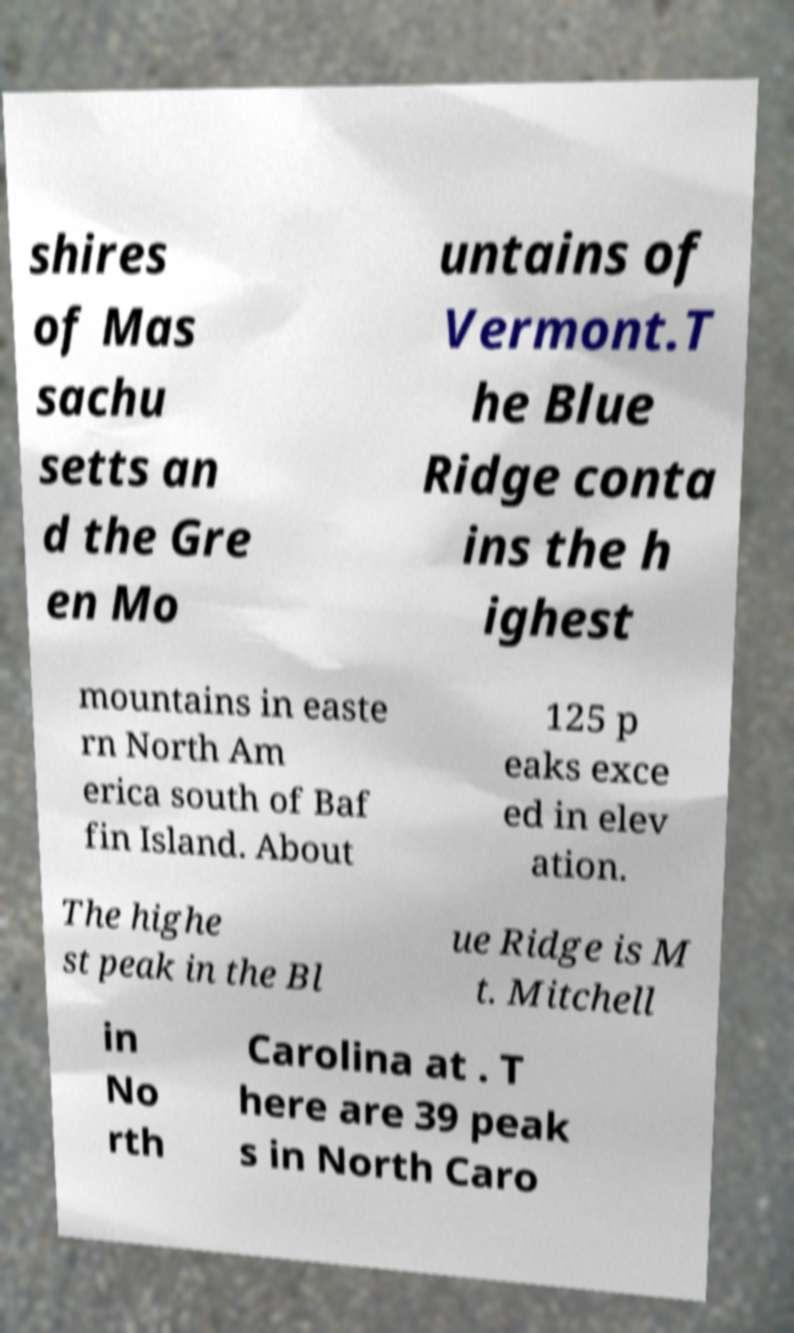I need the written content from this picture converted into text. Can you do that? shires of Mas sachu setts an d the Gre en Mo untains of Vermont.T he Blue Ridge conta ins the h ighest mountains in easte rn North Am erica south of Baf fin Island. About 125 p eaks exce ed in elev ation. The highe st peak in the Bl ue Ridge is M t. Mitchell in No rth Carolina at . T here are 39 peak s in North Caro 